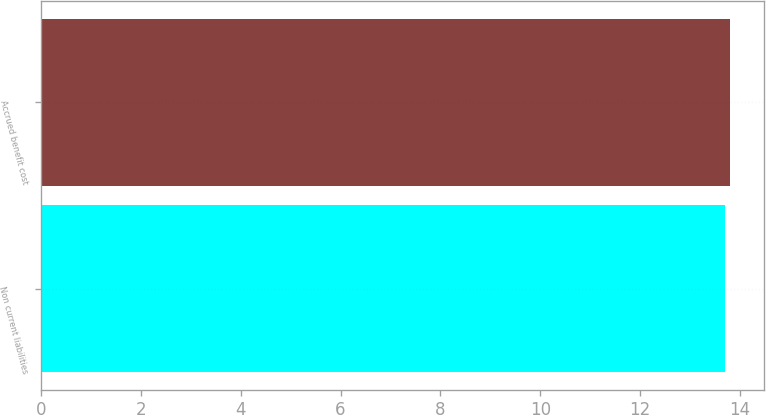<chart> <loc_0><loc_0><loc_500><loc_500><bar_chart><fcel>Non current liabilities<fcel>Accrued benefit cost<nl><fcel>13.7<fcel>13.8<nl></chart> 